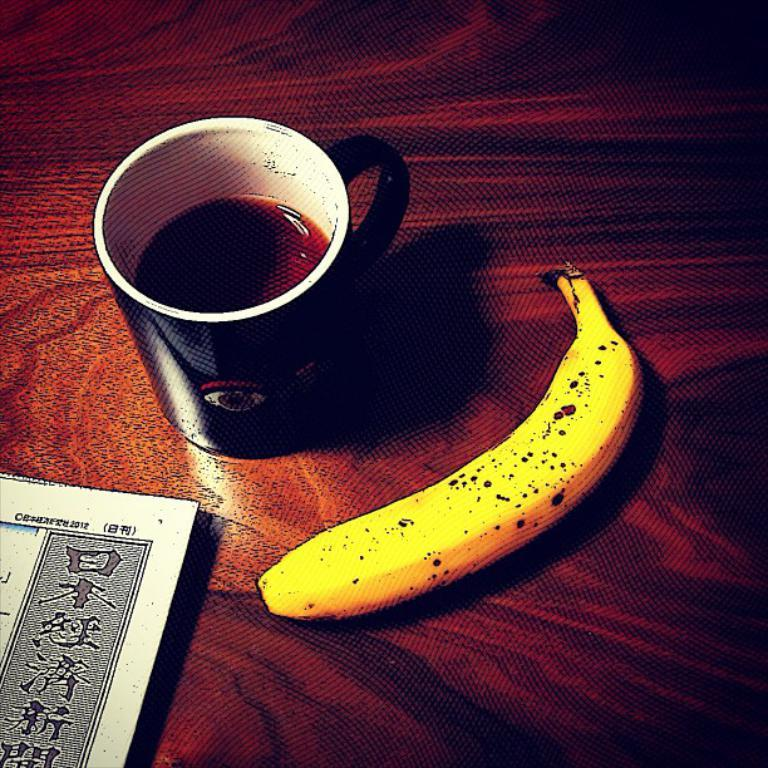What is in the cup that is visible in the image? There is a cup with liquid in the image. What type of fruit is in the image? There is a banana in the image. What type of object is made of paper in the image? There is a paper in the image. What type of surface is present in the image? The wooden surface is present in the image. Can you see the ocean in the image? No, there is no ocean present in the image. What type of vegetable is on the wooden surface in the image? There is no vegetable, specifically a potato, present in the image. 